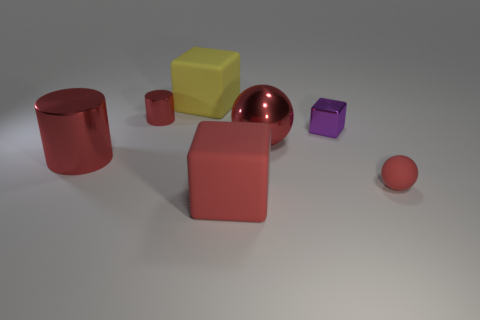What is the shape of the large yellow rubber thing?
Give a very brief answer. Cube. There is a yellow object that is made of the same material as the tiny ball; what is its shape?
Ensure brevity in your answer.  Cube. Is the shape of the tiny red object left of the metal cube the same as  the small matte object?
Keep it short and to the point. No. There is a tiny red object on the left side of the small metallic cube; what shape is it?
Make the answer very short. Cylinder. The large matte thing that is the same color as the big metallic ball is what shape?
Ensure brevity in your answer.  Cube. What number of red metallic things have the same size as the red rubber sphere?
Provide a short and direct response. 1. The tiny block is what color?
Provide a short and direct response. Purple. There is a large cylinder; is it the same color as the tiny object that is on the right side of the metal cube?
Offer a terse response. Yes. The purple thing that is the same material as the large red ball is what size?
Your answer should be very brief. Small. Is there a big matte object that has the same color as the large ball?
Ensure brevity in your answer.  Yes. 